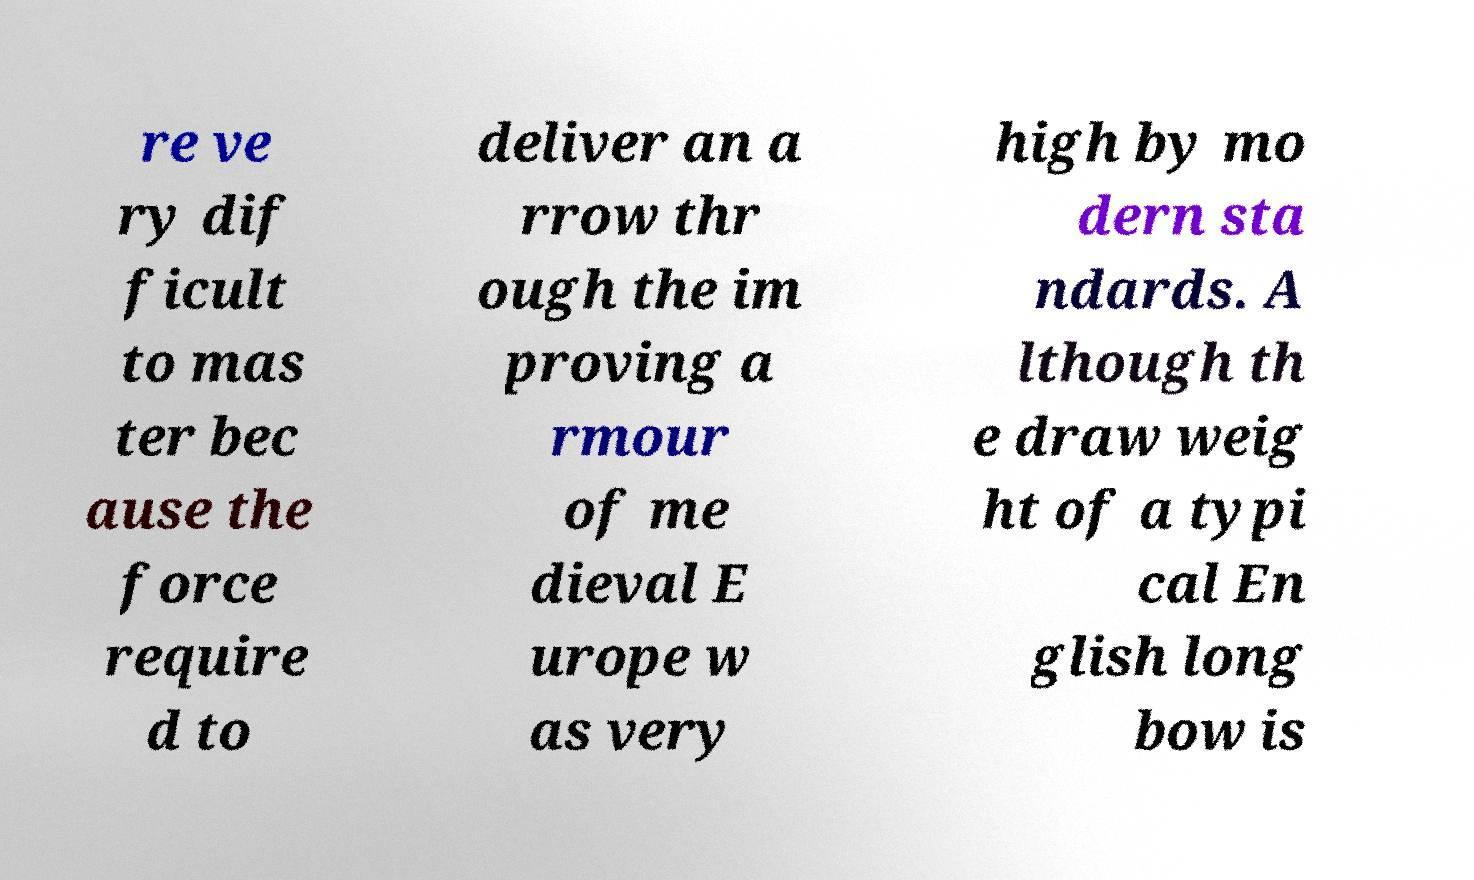Please identify and transcribe the text found in this image. re ve ry dif ficult to mas ter bec ause the force require d to deliver an a rrow thr ough the im proving a rmour of me dieval E urope w as very high by mo dern sta ndards. A lthough th e draw weig ht of a typi cal En glish long bow is 